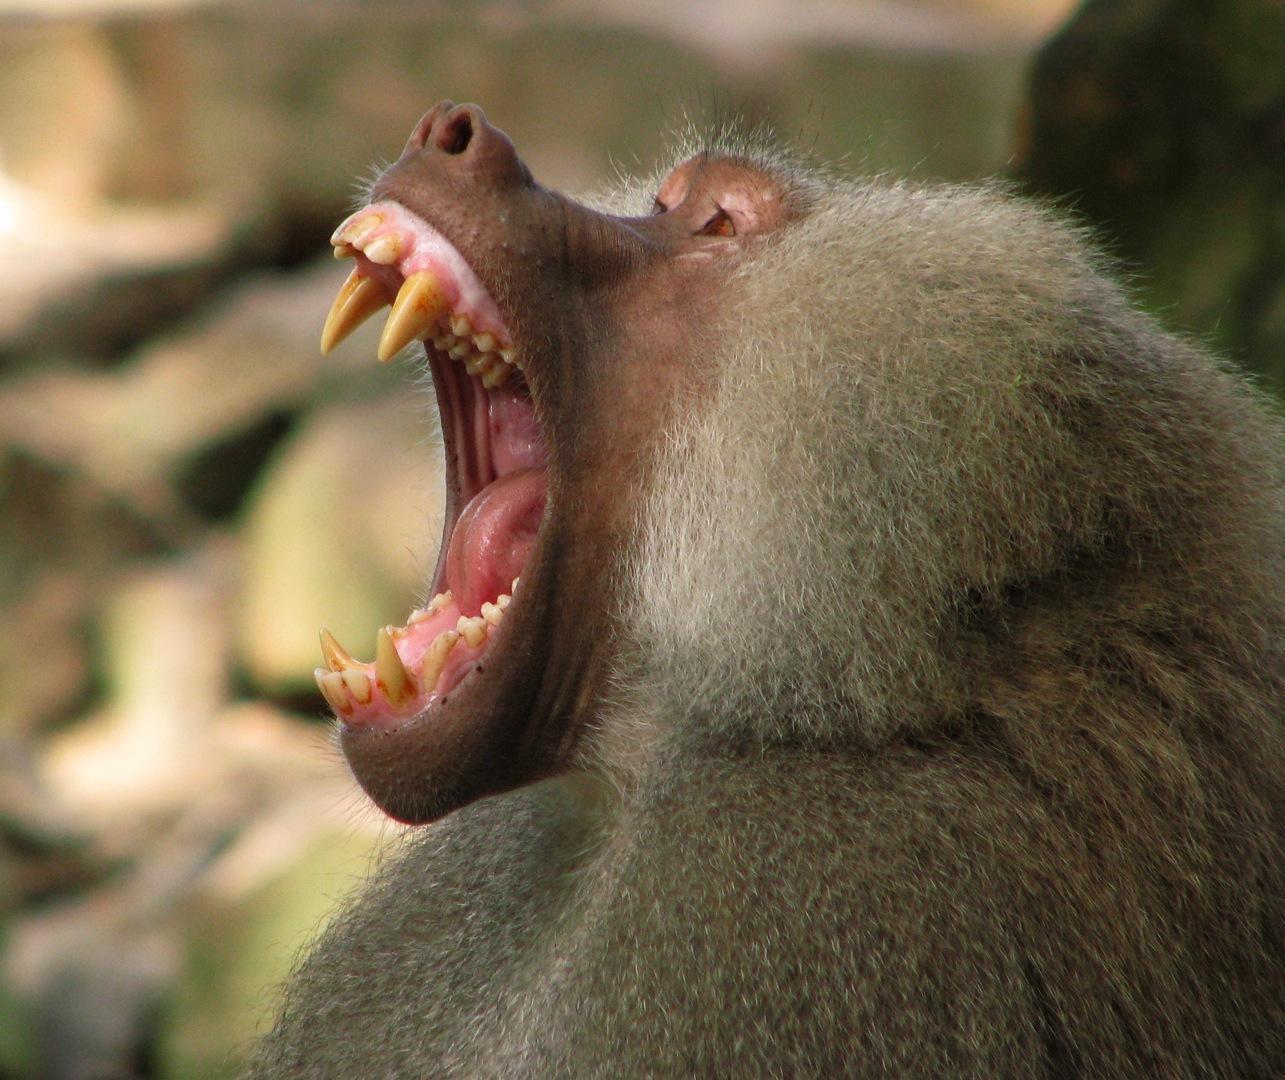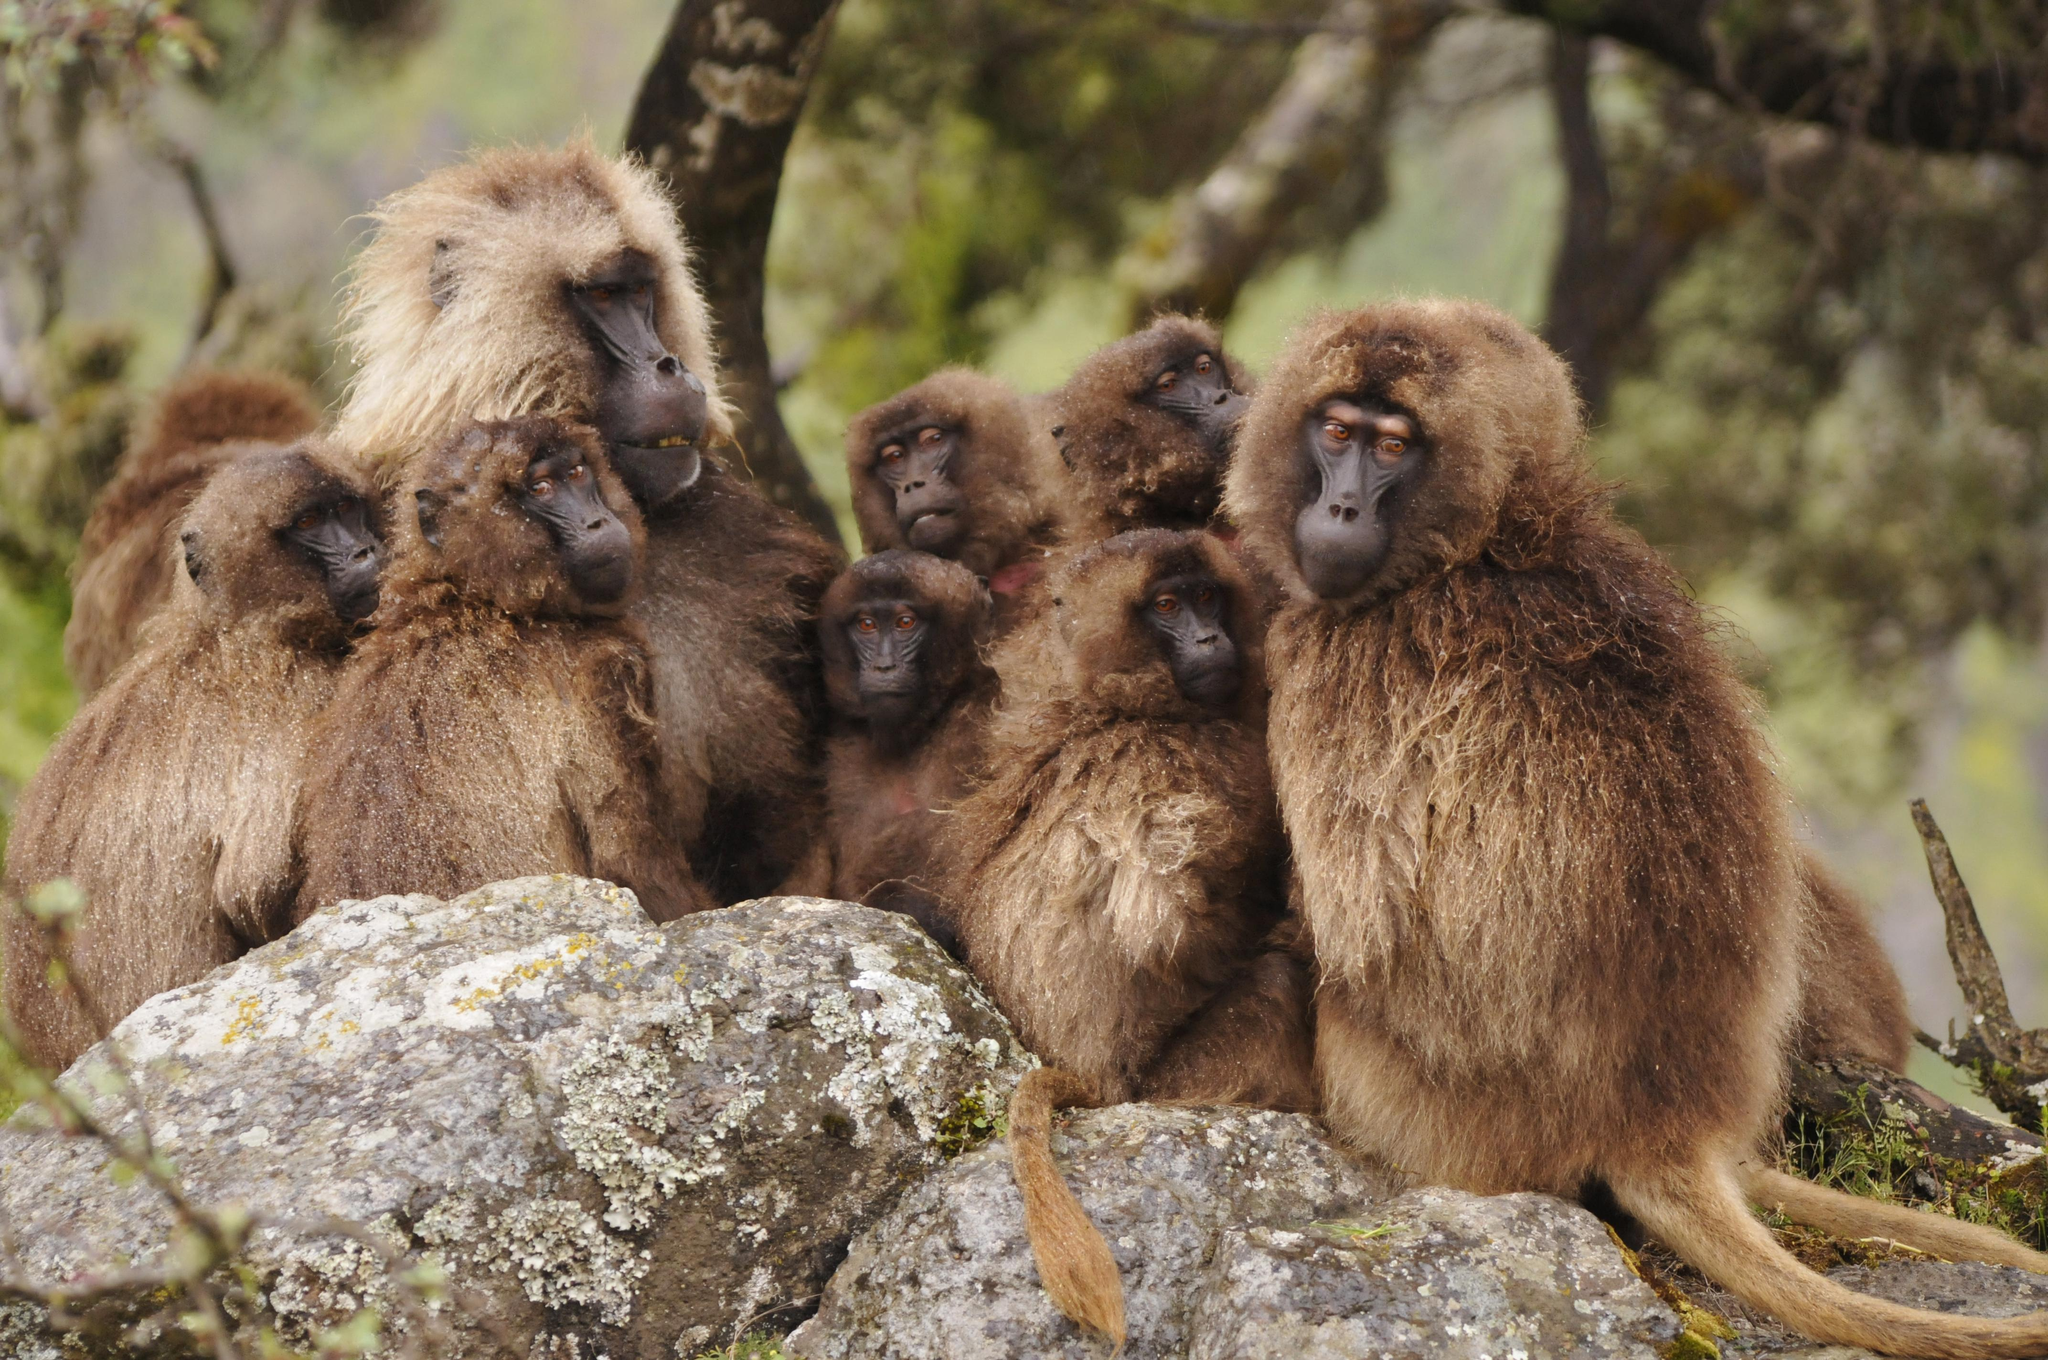The first image is the image on the left, the second image is the image on the right. For the images displayed, is the sentence "A total of four monkeys are shown." factually correct? Answer yes or no. No. The first image is the image on the left, the second image is the image on the right. For the images shown, is this caption "There is exactly one animal baring its teeth in the image on the right." true? Answer yes or no. No. 